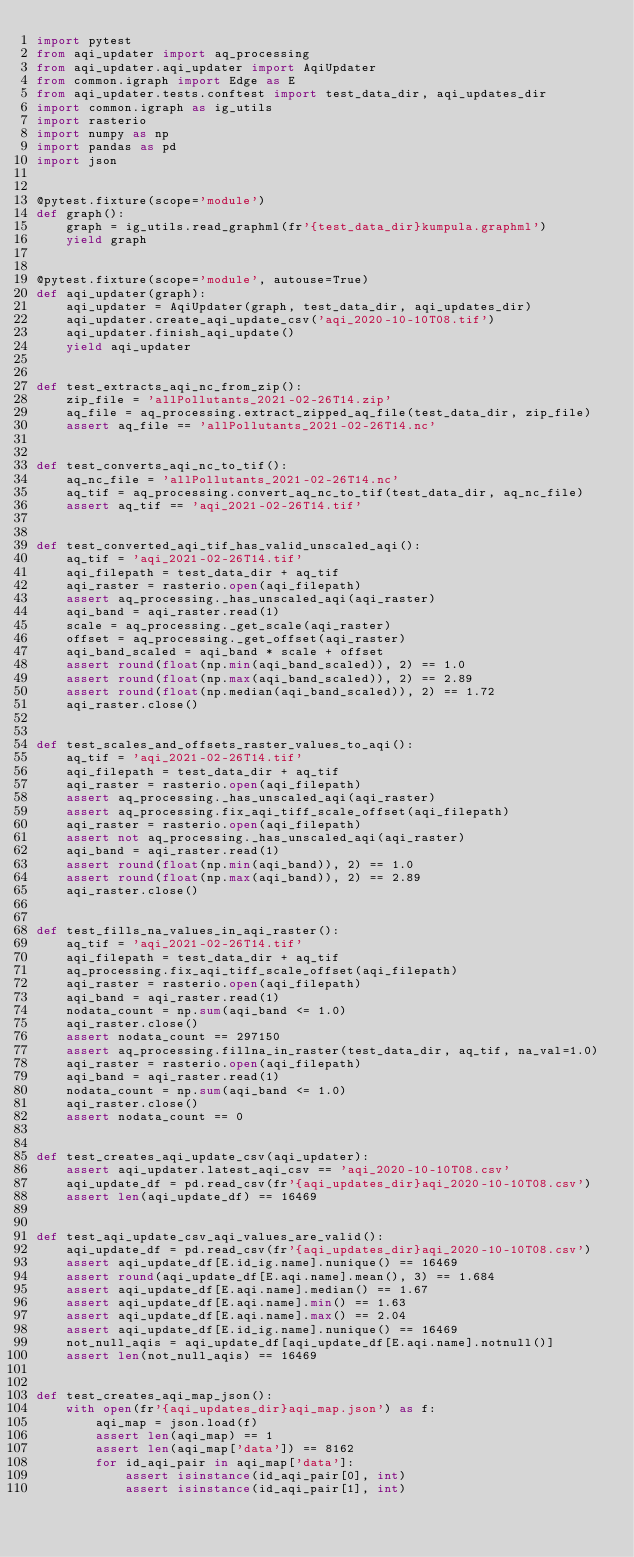<code> <loc_0><loc_0><loc_500><loc_500><_Python_>import pytest
from aqi_updater import aq_processing
from aqi_updater.aqi_updater import AqiUpdater
from common.igraph import Edge as E
from aqi_updater.tests.conftest import test_data_dir, aqi_updates_dir
import common.igraph as ig_utils
import rasterio
import numpy as np
import pandas as pd
import json


@pytest.fixture(scope='module')
def graph():
    graph = ig_utils.read_graphml(fr'{test_data_dir}kumpula.graphml')
    yield graph


@pytest.fixture(scope='module', autouse=True)
def aqi_updater(graph):
    aqi_updater = AqiUpdater(graph, test_data_dir, aqi_updates_dir)
    aqi_updater.create_aqi_update_csv('aqi_2020-10-10T08.tif')
    aqi_updater.finish_aqi_update()
    yield aqi_updater


def test_extracts_aqi_nc_from_zip():
    zip_file = 'allPollutants_2021-02-26T14.zip'
    aq_file = aq_processing.extract_zipped_aq_file(test_data_dir, zip_file)
    assert aq_file == 'allPollutants_2021-02-26T14.nc'


def test_converts_aqi_nc_to_tif():
    aq_nc_file = 'allPollutants_2021-02-26T14.nc'
    aq_tif = aq_processing.convert_aq_nc_to_tif(test_data_dir, aq_nc_file)
    assert aq_tif == 'aqi_2021-02-26T14.tif'


def test_converted_aqi_tif_has_valid_unscaled_aqi():
    aq_tif = 'aqi_2021-02-26T14.tif'
    aqi_filepath = test_data_dir + aq_tif
    aqi_raster = rasterio.open(aqi_filepath)
    assert aq_processing._has_unscaled_aqi(aqi_raster)
    aqi_band = aqi_raster.read(1)
    scale = aq_processing._get_scale(aqi_raster)
    offset = aq_processing._get_offset(aqi_raster)
    aqi_band_scaled = aqi_band * scale + offset
    assert round(float(np.min(aqi_band_scaled)), 2) == 1.0
    assert round(float(np.max(aqi_band_scaled)), 2) == 2.89
    assert round(float(np.median(aqi_band_scaled)), 2) == 1.72
    aqi_raster.close()


def test_scales_and_offsets_raster_values_to_aqi():
    aq_tif = 'aqi_2021-02-26T14.tif'
    aqi_filepath = test_data_dir + aq_tif
    aqi_raster = rasterio.open(aqi_filepath)
    assert aq_processing._has_unscaled_aqi(aqi_raster)
    assert aq_processing.fix_aqi_tiff_scale_offset(aqi_filepath)
    aqi_raster = rasterio.open(aqi_filepath)
    assert not aq_processing._has_unscaled_aqi(aqi_raster)
    aqi_band = aqi_raster.read(1)
    assert round(float(np.min(aqi_band)), 2) == 1.0
    assert round(float(np.max(aqi_band)), 2) == 2.89
    aqi_raster.close()


def test_fills_na_values_in_aqi_raster():
    aq_tif = 'aqi_2021-02-26T14.tif'
    aqi_filepath = test_data_dir + aq_tif
    aq_processing.fix_aqi_tiff_scale_offset(aqi_filepath)
    aqi_raster = rasterio.open(aqi_filepath)
    aqi_band = aqi_raster.read(1)
    nodata_count = np.sum(aqi_band <= 1.0)
    aqi_raster.close()
    assert nodata_count == 297150
    assert aq_processing.fillna_in_raster(test_data_dir, aq_tif, na_val=1.0)
    aqi_raster = rasterio.open(aqi_filepath)
    aqi_band = aqi_raster.read(1)
    nodata_count = np.sum(aqi_band <= 1.0)
    aqi_raster.close()
    assert nodata_count == 0


def test_creates_aqi_update_csv(aqi_updater):
    assert aqi_updater.latest_aqi_csv == 'aqi_2020-10-10T08.csv'
    aqi_update_df = pd.read_csv(fr'{aqi_updates_dir}aqi_2020-10-10T08.csv')
    assert len(aqi_update_df) == 16469


def test_aqi_update_csv_aqi_values_are_valid():
    aqi_update_df = pd.read_csv(fr'{aqi_updates_dir}aqi_2020-10-10T08.csv')
    assert aqi_update_df[E.id_ig.name].nunique() == 16469
    assert round(aqi_update_df[E.aqi.name].mean(), 3) == 1.684
    assert aqi_update_df[E.aqi.name].median() == 1.67
    assert aqi_update_df[E.aqi.name].min() == 1.63
    assert aqi_update_df[E.aqi.name].max() == 2.04
    assert aqi_update_df[E.id_ig.name].nunique() == 16469
    not_null_aqis = aqi_update_df[aqi_update_df[E.aqi.name].notnull()]
    assert len(not_null_aqis) == 16469


def test_creates_aqi_map_json():
    with open(fr'{aqi_updates_dir}aqi_map.json') as f:
        aqi_map = json.load(f)
        assert len(aqi_map) == 1
        assert len(aqi_map['data']) == 8162
        for id_aqi_pair in aqi_map['data']:
            assert isinstance(id_aqi_pair[0], int) 
            assert isinstance(id_aqi_pair[1], int)
</code> 